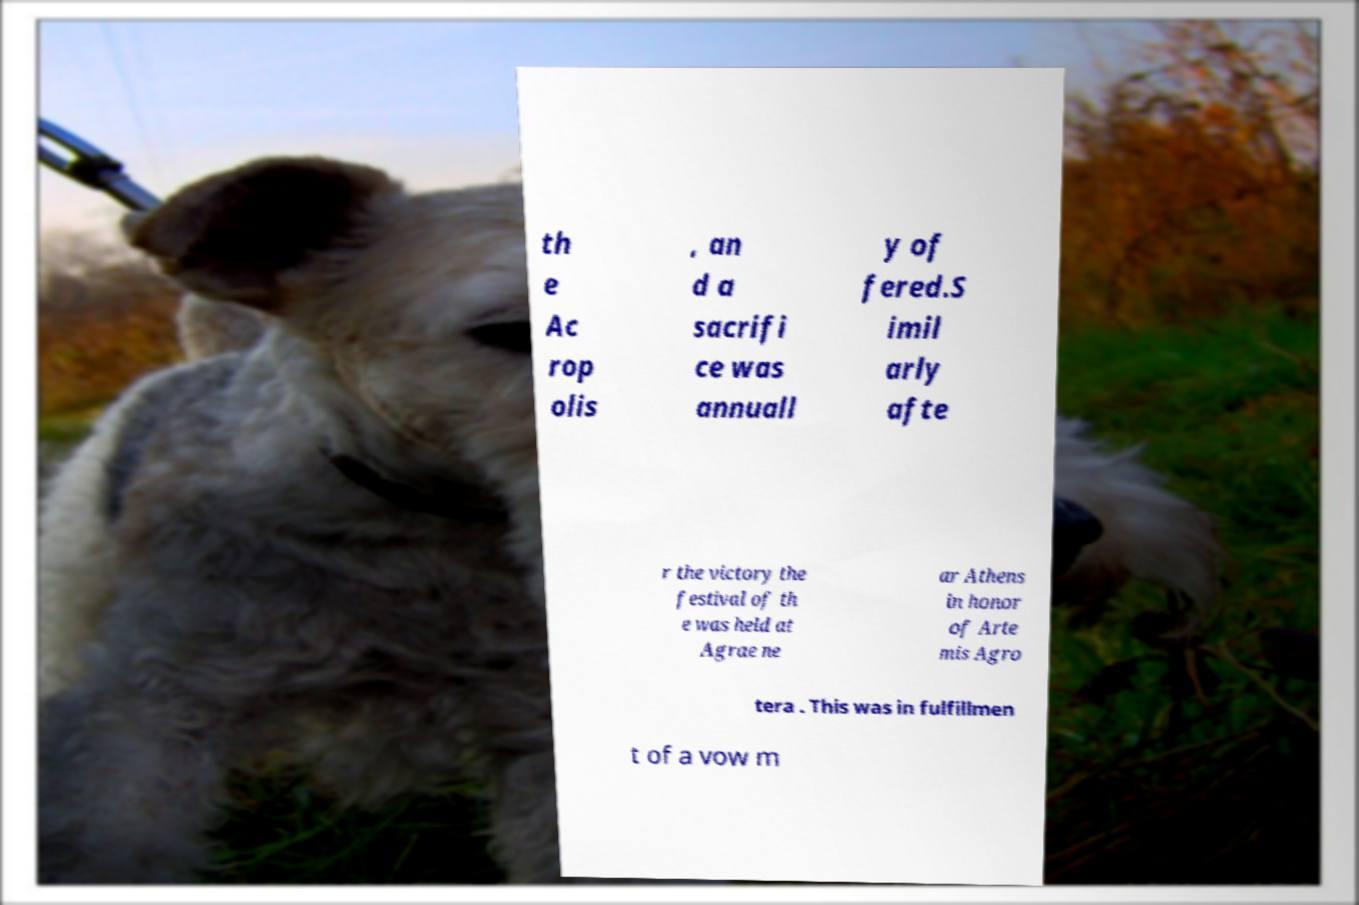Please read and relay the text visible in this image. What does it say? th e Ac rop olis , an d a sacrifi ce was annuall y of fered.S imil arly afte r the victory the festival of th e was held at Agrae ne ar Athens in honor of Arte mis Agro tera . This was in fulfillmen t of a vow m 